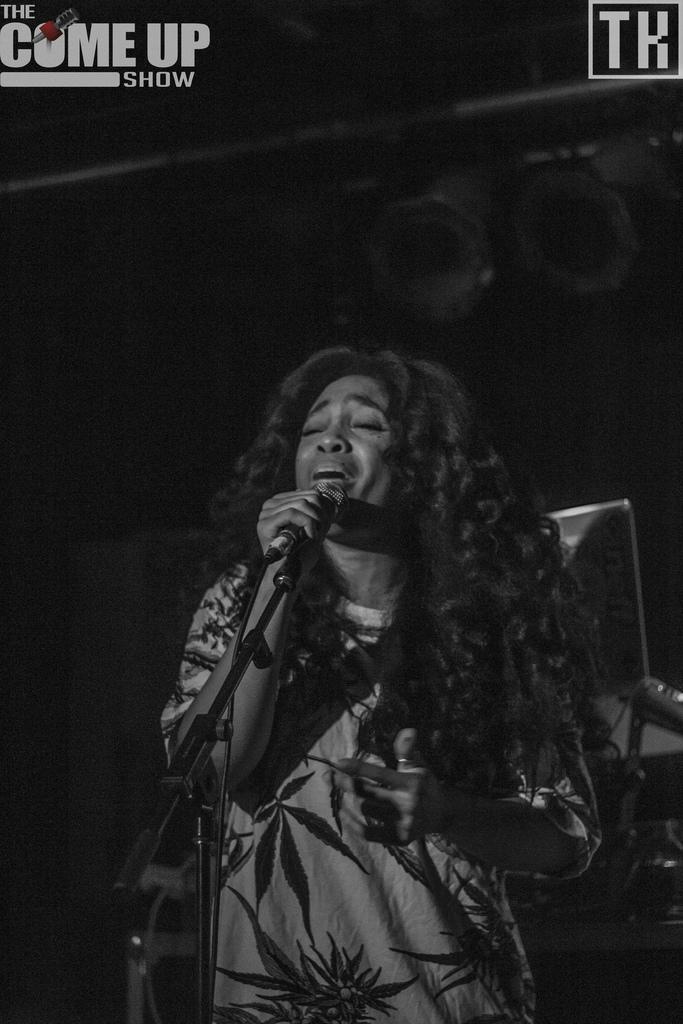Who is the main subject in the image? There is a woman in the image. What is the woman doing in the image? The woman is standing on the floor and holding a microphone in her hand. What can be seen in the background of the image? There are poles and a laptop in the background of the image. What type of berry is the woman holding in the image? There is no berry present in the image; the woman is holding a microphone. Where is the market located in the image? There is no market present in the image. 